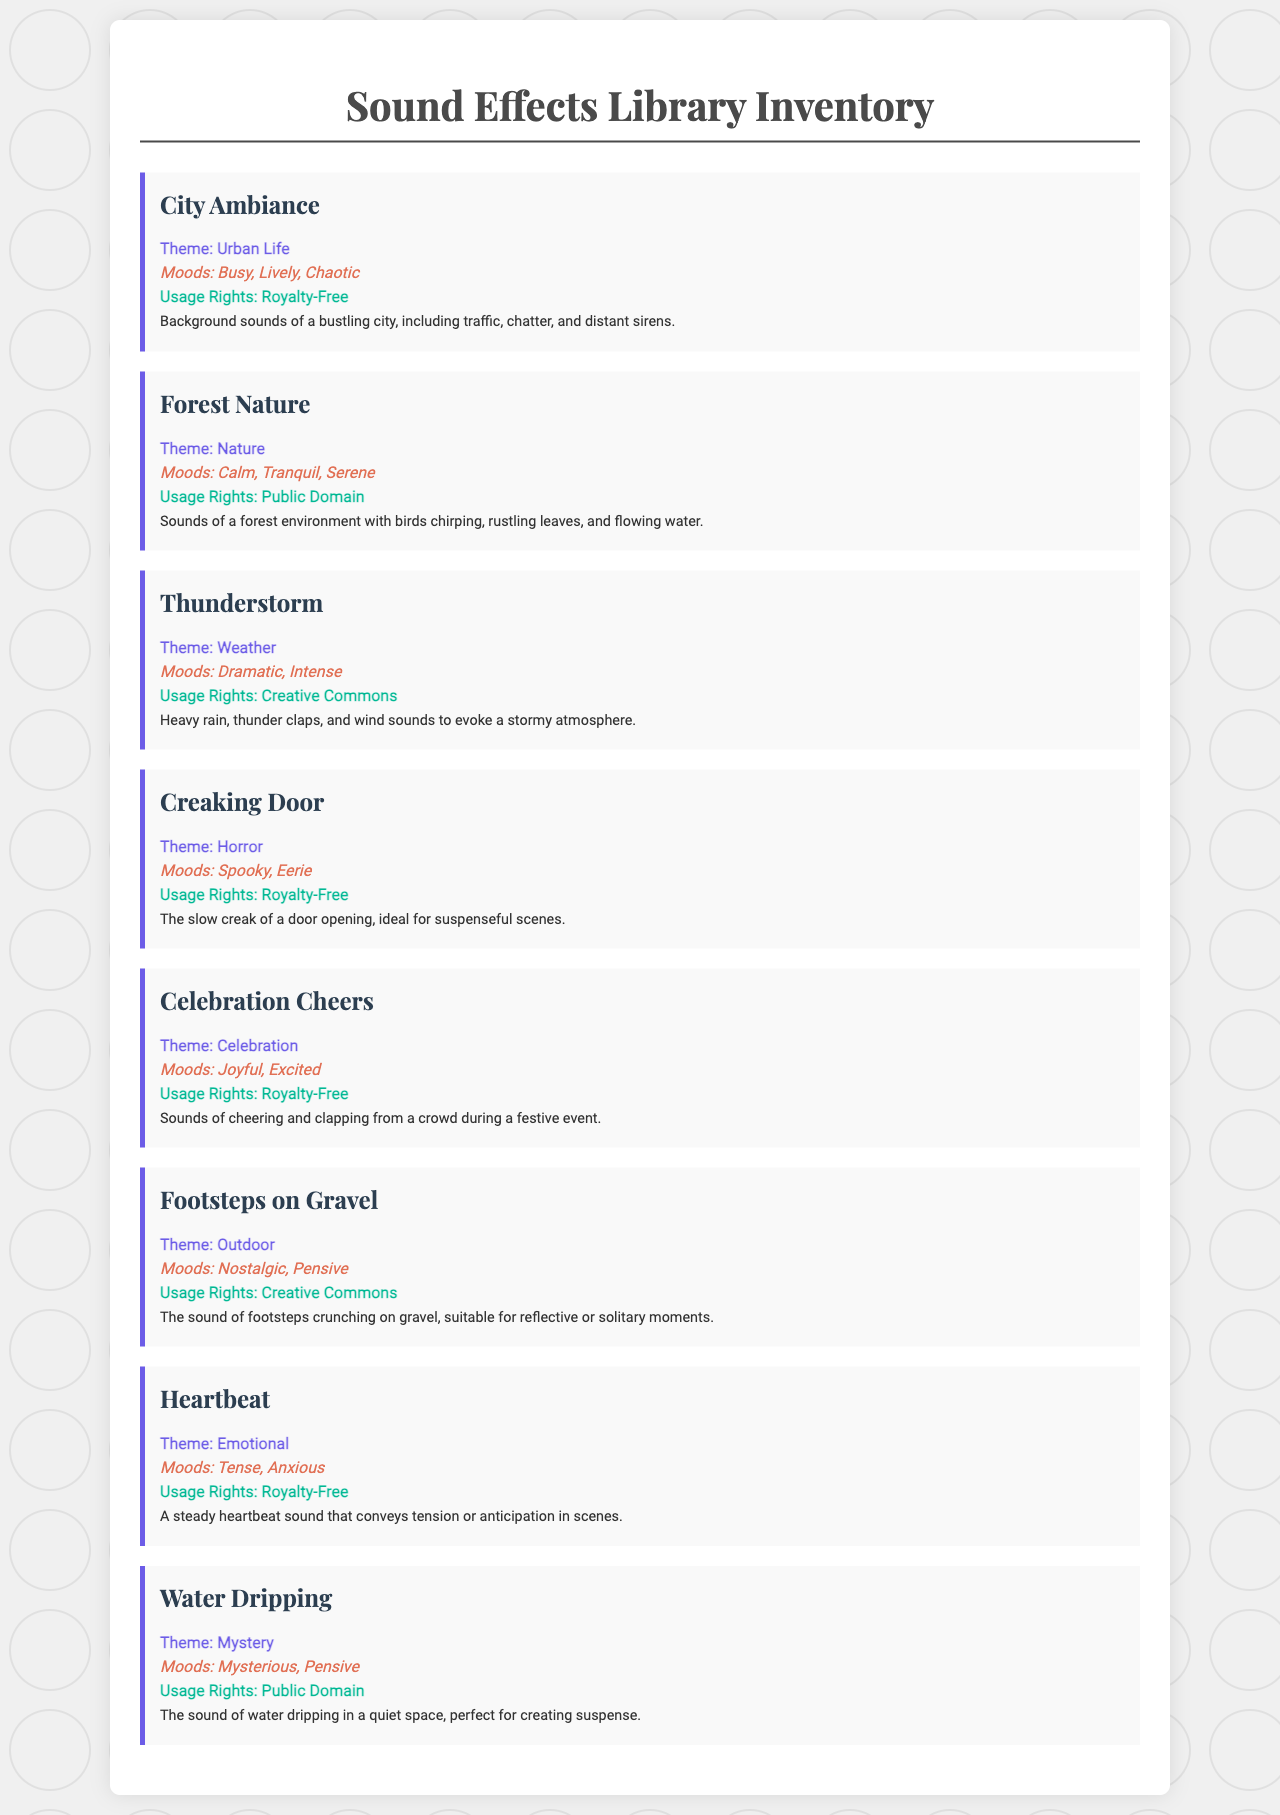What is the theme of the sound effect "City Ambiance"? The theme of the sound effect "City Ambiance" is explicitly listed in the document as "Urban Life."
Answer: Urban Life What is the mood associated with the "Forest Nature" sound effect? The moods related to "Forest Nature" are stated in the document as "Calm, Tranquil, Serene."
Answer: Calm, Tranquil, Serene What type of usage rights does the "Thunderstorm" sound effect have? The usage rights for "Thunderstorm" are described in the document as "Creative Commons."
Answer: Creative Commons How many sound effects are listed in the document? The document lists a total of eight distinct sound effects, as can be counted in the inventory section.
Answer: 8 Which sound effect is described as having a "Spooky" mood? The document states that the "Creaking Door" sound effect is characterized by the mood "Spooky."
Answer: Creaking Door What is the mood for the sound effect "Heartbeat"? The document states that the mood for "Heartbeat" is "Tense, Anxious."
Answer: Tense, Anxious What type of theme is associated with the sound effect "Celebration Cheers"? The theme for "Celebration Cheers" is identified in the document as "Celebration."
Answer: Celebration Which sound effect has a description involving water? The sound effect described as involving water is "Water Dripping" in the document.
Answer: Water Dripping 